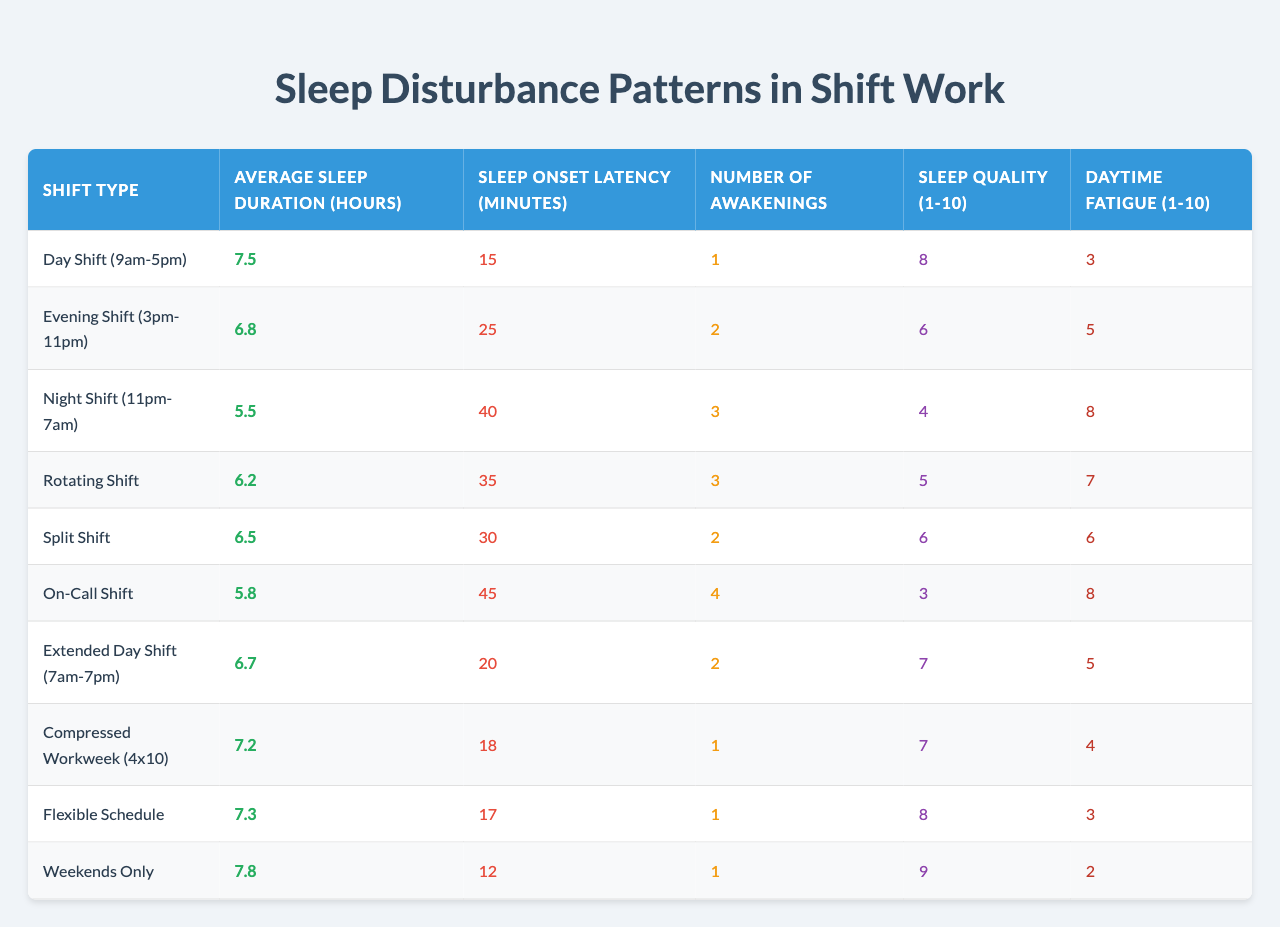What is the average sleep duration for those on a Day Shift? The table indicates that the average sleep duration for the Day Shift (9am-5pm) is 7.5 hours.
Answer: 7.5 hours Which shift has the highest sleep quality rating? The Weekends Only shift has the highest sleep quality rating of 9.
Answer: 9 What is the difference in average sleep duration between Night Shift and Day Shift? The Night Shift has an average sleep duration of 5.5 hours, and the Day Shift has 7.5 hours. Therefore, the difference is 7.5 - 5.5 = 2 hours.
Answer: 2 hours Is the average sleep onset latency longer for Split Shift than for Day Shift? The Split Shift has an onset latency of 30 minutes, while the Day Shift has 15 minutes, so Split Shift's latency is longer.
Answer: Yes What is the total number of awakenings for Evening Shift and Night Shift combined? The Evening Shift has 2 awakenings and the Night Shift has 3. The total is 2 + 3 = 5.
Answer: 5 Which shifts have a daytime fatigue rating of 3? The Day Shift and Flexible Schedule both have a daytime fatigue rating of 3.
Answer: Day Shift and Flexible Schedule What is the average sleep quality across all shifts? To find the average, sum the sleep quality ratings: (8 + 6 + 4 + 5 + 6 + 3 + 7 + 7 + 8 + 9) = 63. There are 10 shifts. So the average is 63/10 = 6.3.
Answer: 6.3 Is the average sleep duration for On-Call Shift less than 6 hours? The On-Call Shift has an average sleep duration of 5.8 hours which is less than 6 hours.
Answer: Yes What is the shift type with the highest number of awakenings? The On-Call Shift has the highest number of awakenings, which is 4.
Answer: On-Call Shift If you were to rank the shifts based on average sleep duration, which would be in the second place? The second place based on average sleep duration is the Compressed Workweek with 7.2 hours, after Weekends Only with 7.8 hours.
Answer: Compressed Workweek What is the average daytime fatigue rating for Night Shift and Rotating Shift? The Night Shift has a daytime fatigue of 8, and the Rotating Shift has 7. The average is (8 + 7)/2 = 7.5.
Answer: 7.5 